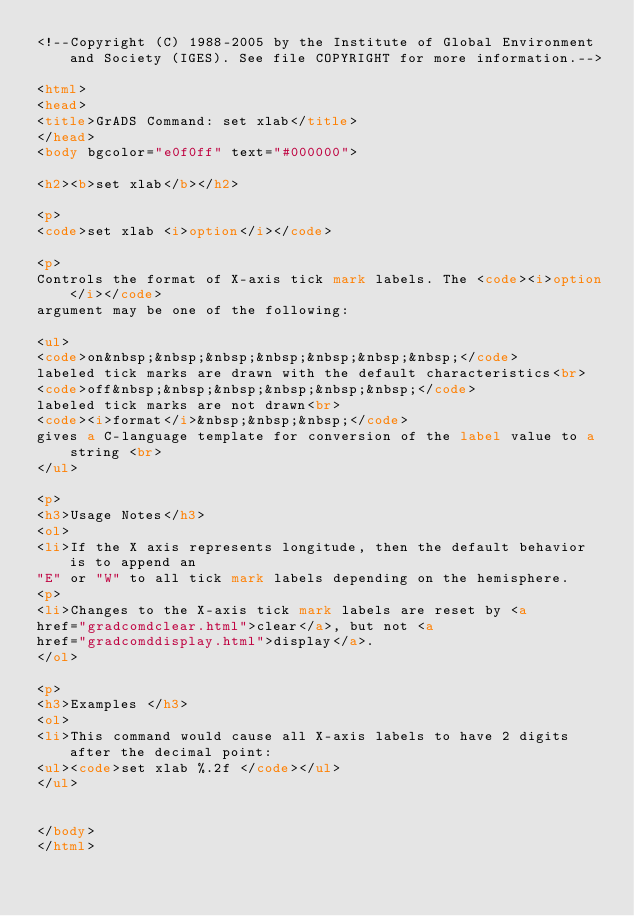Convert code to text. <code><loc_0><loc_0><loc_500><loc_500><_HTML_><!--Copyright (C) 1988-2005 by the Institute of Global Environment and Society (IGES). See file COPYRIGHT for more information.-->

<html>
<head>
<title>GrADS Command: set xlab</title>
</head>
<body bgcolor="e0f0ff" text="#000000">

<h2><b>set xlab</b></h2>

<p>
<code>set xlab <i>option</i></code>

<p>
Controls the format of X-axis tick mark labels. The <code><i>option</i></code>
argument may be one of the following:

<ul>
<code>on&nbsp;&nbsp;&nbsp;&nbsp;&nbsp;&nbsp;&nbsp;</code>
labeled tick marks are drawn with the default characteristics<br>
<code>off&nbsp;&nbsp;&nbsp;&nbsp;&nbsp;&nbsp;</code>
labeled tick marks are not drawn<br>
<code><i>format</i>&nbsp;&nbsp;&nbsp;</code>
gives a C-language template for conversion of the label value to a string <br>
</ul>

<p>
<h3>Usage Notes</h3>
<ol>
<li>If the X axis represents longitude, then the default behavior is to append an 
"E" or "W" to all tick mark labels depending on the hemisphere. 
<p>
<li>Changes to the X-axis tick mark labels are reset by <a
href="gradcomdclear.html">clear</a>, but not <a
href="gradcomddisplay.html">display</a>.
</ol>

<p>
<h3>Examples </h3>
<ol>
<li>This command would cause all X-axis labels to have 2 digits after the decimal point:
<ul><code>set xlab %.2f </code></ul>
</ul>


</body>
</html>
</code> 